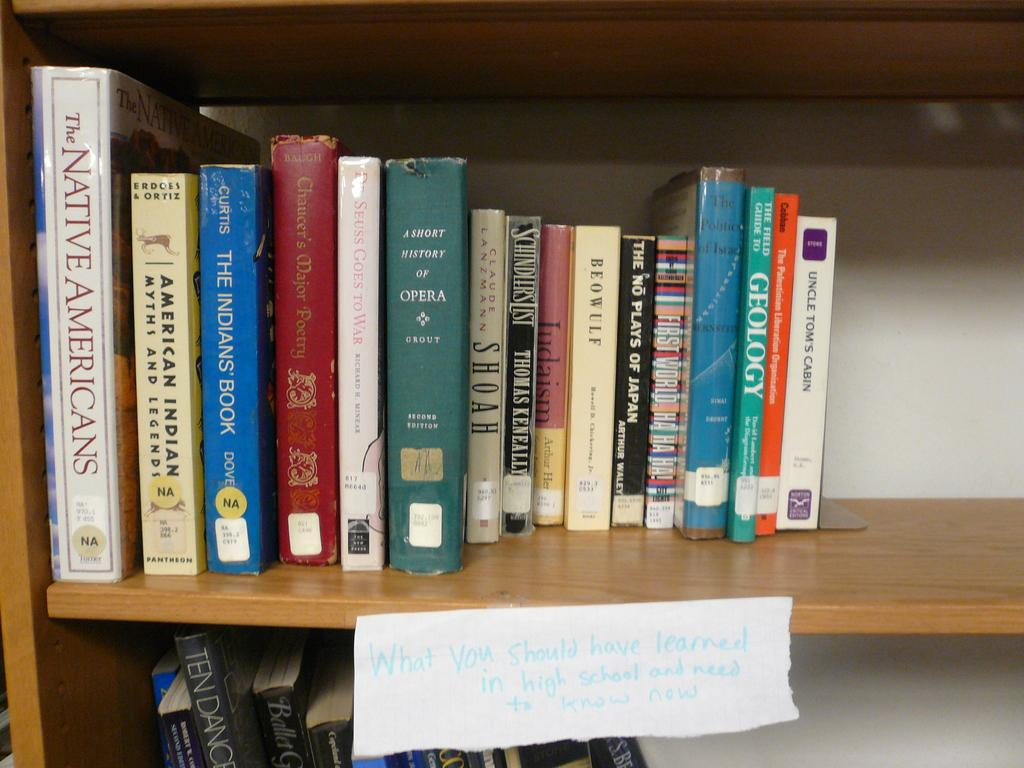Provide a one-sentence caption for the provided image. A collection of a dozen or so books about Native Americans sits on a shelf. 